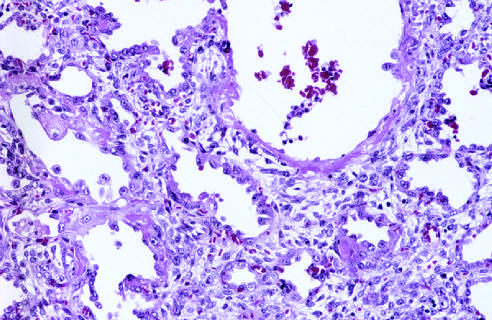re numerous reactive type ii pneumocytes seen at this stage, associated with regeneration and repair?
Answer the question using a single word or phrase. Yes 